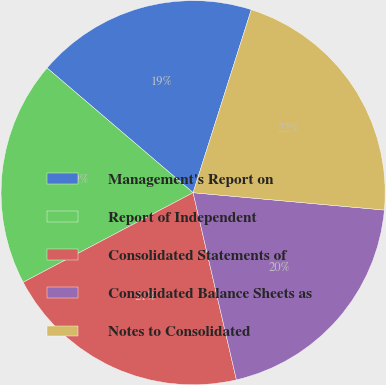Convert chart. <chart><loc_0><loc_0><loc_500><loc_500><pie_chart><fcel>Management's Report on<fcel>Report of Independent<fcel>Consolidated Statements of<fcel>Consolidated Balance Sheets as<fcel>Notes to Consolidated<nl><fcel>18.65%<fcel>18.97%<fcel>20.9%<fcel>19.94%<fcel>21.54%<nl></chart> 